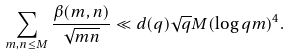<formula> <loc_0><loc_0><loc_500><loc_500>\sum _ { m , n \leq M } \frac { \beta ( m , n ) } { \sqrt { m n } } \ll d ( q ) \sqrt { q } M ( \log { q m } ) ^ { 4 } .</formula> 